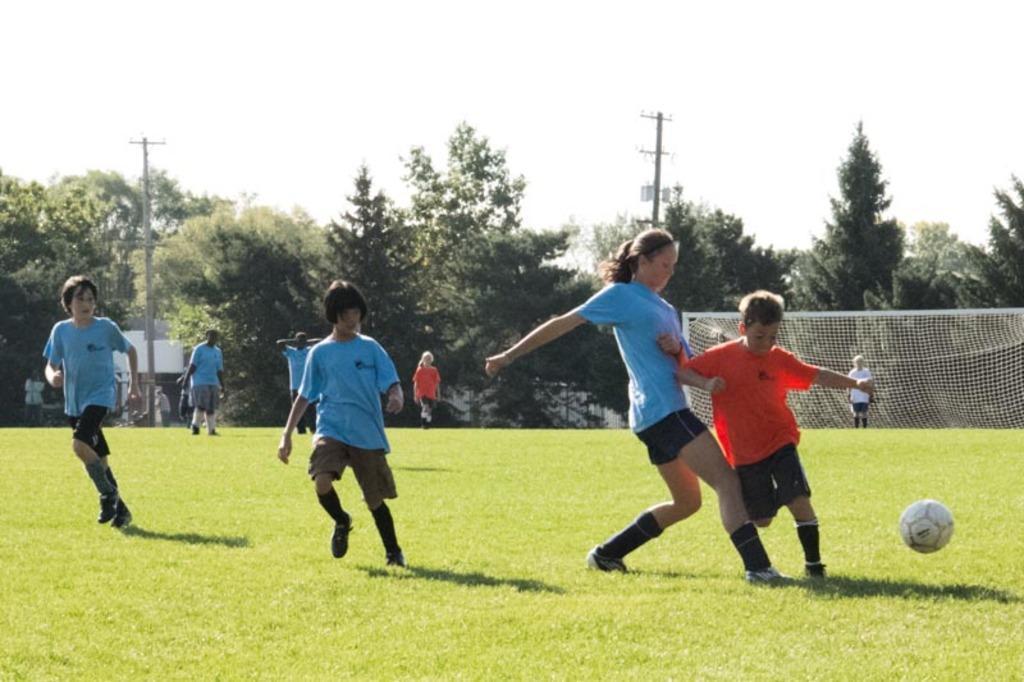Describe this image in one or two sentences. In this image I can see lot of children on the grass and there is a football over here. In the background I can see the net and lot of trees, 2 poles and the sky. 